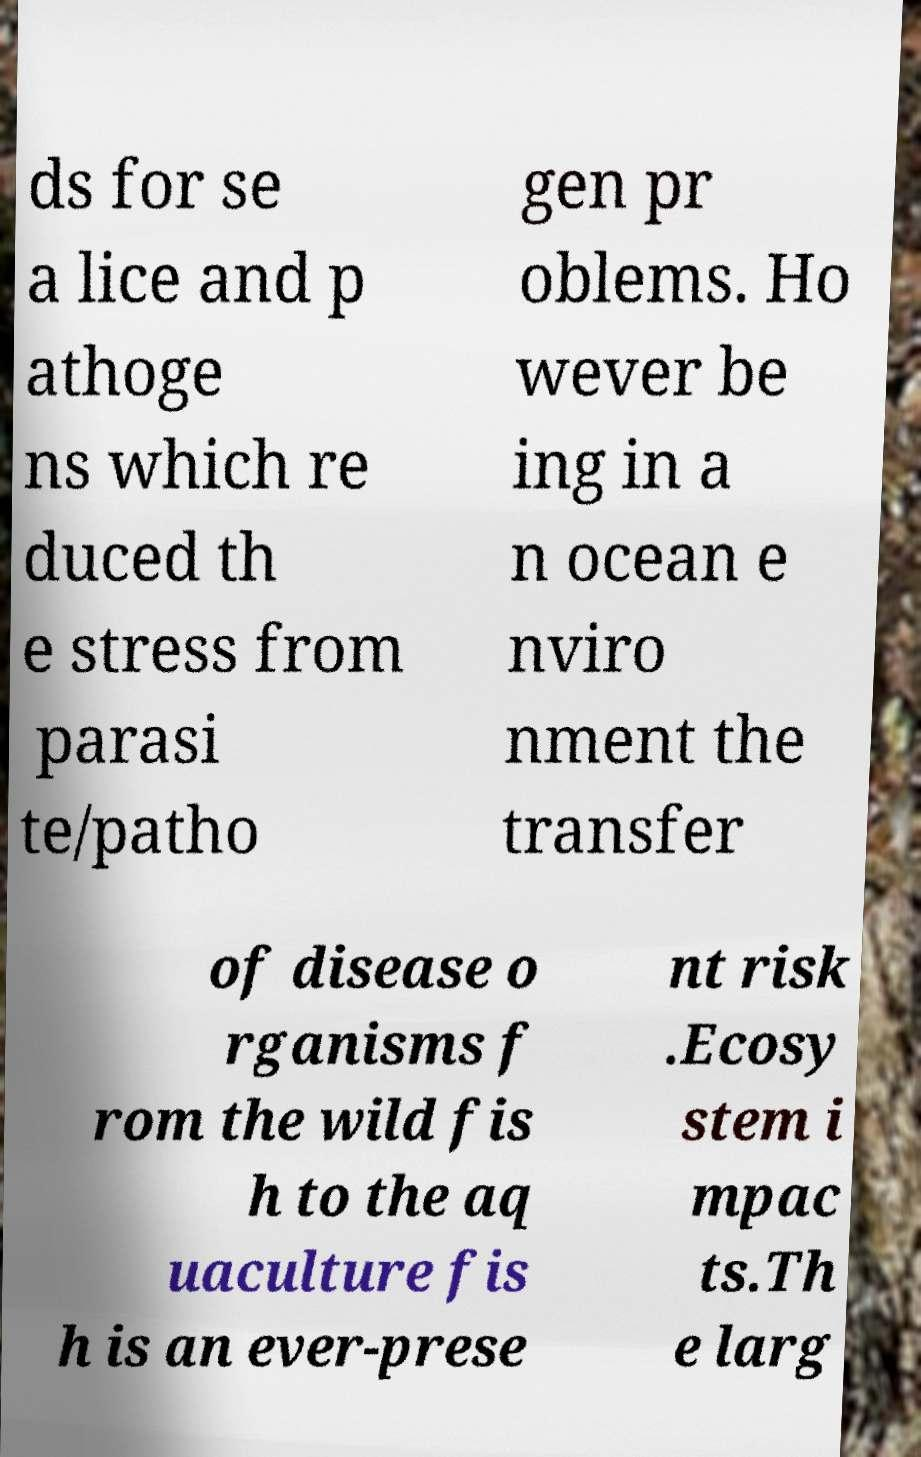What messages or text are displayed in this image? I need them in a readable, typed format. ds for se a lice and p athoge ns which re duced th e stress from parasi te/patho gen pr oblems. Ho wever be ing in a n ocean e nviro nment the transfer of disease o rganisms f rom the wild fis h to the aq uaculture fis h is an ever-prese nt risk .Ecosy stem i mpac ts.Th e larg 